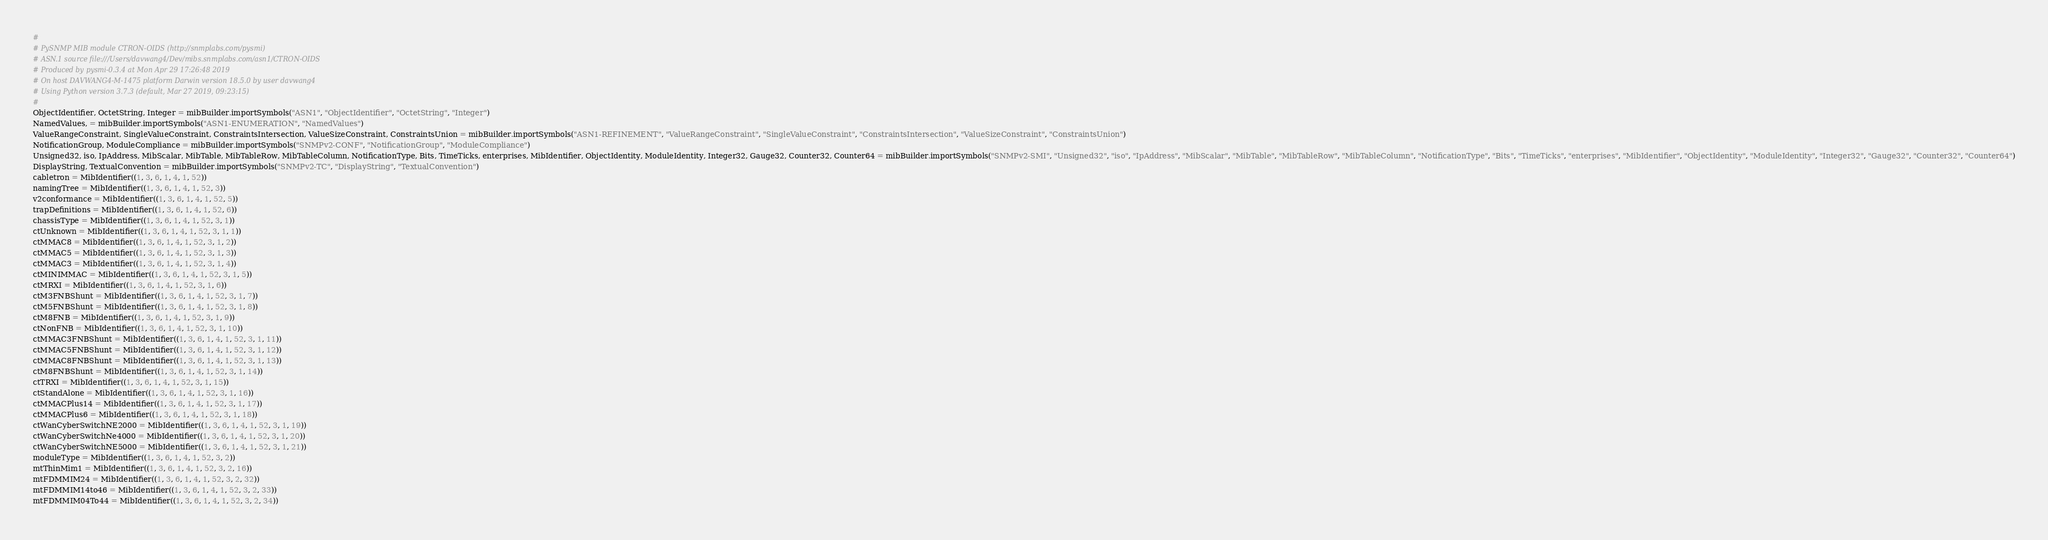<code> <loc_0><loc_0><loc_500><loc_500><_Python_>#
# PySNMP MIB module CTRON-OIDS (http://snmplabs.com/pysmi)
# ASN.1 source file:///Users/davwang4/Dev/mibs.snmplabs.com/asn1/CTRON-OIDS
# Produced by pysmi-0.3.4 at Mon Apr 29 17:26:48 2019
# On host DAVWANG4-M-1475 platform Darwin version 18.5.0 by user davwang4
# Using Python version 3.7.3 (default, Mar 27 2019, 09:23:15) 
#
ObjectIdentifier, OctetString, Integer = mibBuilder.importSymbols("ASN1", "ObjectIdentifier", "OctetString", "Integer")
NamedValues, = mibBuilder.importSymbols("ASN1-ENUMERATION", "NamedValues")
ValueRangeConstraint, SingleValueConstraint, ConstraintsIntersection, ValueSizeConstraint, ConstraintsUnion = mibBuilder.importSymbols("ASN1-REFINEMENT", "ValueRangeConstraint", "SingleValueConstraint", "ConstraintsIntersection", "ValueSizeConstraint", "ConstraintsUnion")
NotificationGroup, ModuleCompliance = mibBuilder.importSymbols("SNMPv2-CONF", "NotificationGroup", "ModuleCompliance")
Unsigned32, iso, IpAddress, MibScalar, MibTable, MibTableRow, MibTableColumn, NotificationType, Bits, TimeTicks, enterprises, MibIdentifier, ObjectIdentity, ModuleIdentity, Integer32, Gauge32, Counter32, Counter64 = mibBuilder.importSymbols("SNMPv2-SMI", "Unsigned32", "iso", "IpAddress", "MibScalar", "MibTable", "MibTableRow", "MibTableColumn", "NotificationType", "Bits", "TimeTicks", "enterprises", "MibIdentifier", "ObjectIdentity", "ModuleIdentity", "Integer32", "Gauge32", "Counter32", "Counter64")
DisplayString, TextualConvention = mibBuilder.importSymbols("SNMPv2-TC", "DisplayString", "TextualConvention")
cabletron = MibIdentifier((1, 3, 6, 1, 4, 1, 52))
namingTree = MibIdentifier((1, 3, 6, 1, 4, 1, 52, 3))
v2conformance = MibIdentifier((1, 3, 6, 1, 4, 1, 52, 5))
trapDefinitions = MibIdentifier((1, 3, 6, 1, 4, 1, 52, 6))
chassisType = MibIdentifier((1, 3, 6, 1, 4, 1, 52, 3, 1))
ctUnknown = MibIdentifier((1, 3, 6, 1, 4, 1, 52, 3, 1, 1))
ctMMAC8 = MibIdentifier((1, 3, 6, 1, 4, 1, 52, 3, 1, 2))
ctMMAC5 = MibIdentifier((1, 3, 6, 1, 4, 1, 52, 3, 1, 3))
ctMMAC3 = MibIdentifier((1, 3, 6, 1, 4, 1, 52, 3, 1, 4))
ctMINIMMAC = MibIdentifier((1, 3, 6, 1, 4, 1, 52, 3, 1, 5))
ctMRXI = MibIdentifier((1, 3, 6, 1, 4, 1, 52, 3, 1, 6))
ctM3FNBShunt = MibIdentifier((1, 3, 6, 1, 4, 1, 52, 3, 1, 7))
ctM5FNBShunt = MibIdentifier((1, 3, 6, 1, 4, 1, 52, 3, 1, 8))
ctM8FNB = MibIdentifier((1, 3, 6, 1, 4, 1, 52, 3, 1, 9))
ctNonFNB = MibIdentifier((1, 3, 6, 1, 4, 1, 52, 3, 1, 10))
ctMMAC3FNBShunt = MibIdentifier((1, 3, 6, 1, 4, 1, 52, 3, 1, 11))
ctMMAC5FNBShunt = MibIdentifier((1, 3, 6, 1, 4, 1, 52, 3, 1, 12))
ctMMAC8FNBShunt = MibIdentifier((1, 3, 6, 1, 4, 1, 52, 3, 1, 13))
ctM8FNBShunt = MibIdentifier((1, 3, 6, 1, 4, 1, 52, 3, 1, 14))
ctTRXI = MibIdentifier((1, 3, 6, 1, 4, 1, 52, 3, 1, 15))
ctStandAlone = MibIdentifier((1, 3, 6, 1, 4, 1, 52, 3, 1, 16))
ctMMACPlus14 = MibIdentifier((1, 3, 6, 1, 4, 1, 52, 3, 1, 17))
ctMMACPlus6 = MibIdentifier((1, 3, 6, 1, 4, 1, 52, 3, 1, 18))
ctWanCyberSwitchNE2000 = MibIdentifier((1, 3, 6, 1, 4, 1, 52, 3, 1, 19))
ctWanCyberSwitchNe4000 = MibIdentifier((1, 3, 6, 1, 4, 1, 52, 3, 1, 20))
ctWanCyberSwitchNE5000 = MibIdentifier((1, 3, 6, 1, 4, 1, 52, 3, 1, 21))
moduleType = MibIdentifier((1, 3, 6, 1, 4, 1, 52, 3, 2))
mtThinMim1 = MibIdentifier((1, 3, 6, 1, 4, 1, 52, 3, 2, 16))
mtFDMMIM24 = MibIdentifier((1, 3, 6, 1, 4, 1, 52, 3, 2, 32))
mtFDMMIM14to46 = MibIdentifier((1, 3, 6, 1, 4, 1, 52, 3, 2, 33))
mtFDMMIM04To44 = MibIdentifier((1, 3, 6, 1, 4, 1, 52, 3, 2, 34))</code> 